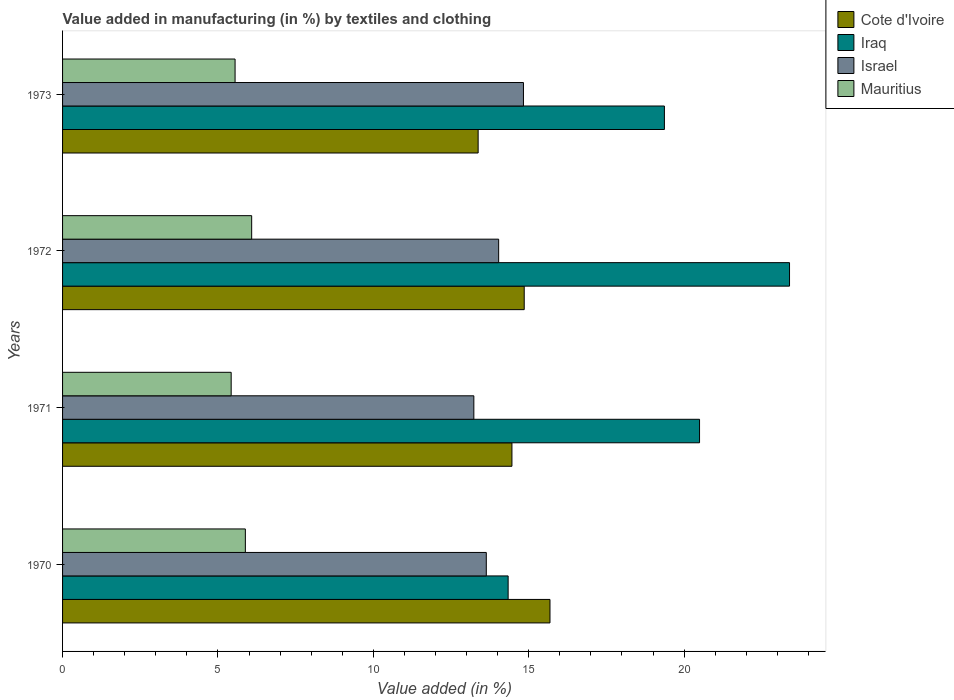How many different coloured bars are there?
Offer a terse response. 4. Are the number of bars per tick equal to the number of legend labels?
Your response must be concise. Yes. How many bars are there on the 1st tick from the top?
Provide a succinct answer. 4. What is the percentage of value added in manufacturing by textiles and clothing in Mauritius in 1970?
Provide a succinct answer. 5.88. Across all years, what is the maximum percentage of value added in manufacturing by textiles and clothing in Israel?
Give a very brief answer. 14.83. Across all years, what is the minimum percentage of value added in manufacturing by textiles and clothing in Mauritius?
Your answer should be compact. 5.43. In which year was the percentage of value added in manufacturing by textiles and clothing in Mauritius maximum?
Your response must be concise. 1972. In which year was the percentage of value added in manufacturing by textiles and clothing in Israel minimum?
Offer a terse response. 1971. What is the total percentage of value added in manufacturing by textiles and clothing in Mauritius in the graph?
Offer a very short reply. 22.94. What is the difference between the percentage of value added in manufacturing by textiles and clothing in Iraq in 1970 and that in 1972?
Provide a short and direct response. -9.06. What is the difference between the percentage of value added in manufacturing by textiles and clothing in Iraq in 1971 and the percentage of value added in manufacturing by textiles and clothing in Cote d'Ivoire in 1973?
Keep it short and to the point. 7.12. What is the average percentage of value added in manufacturing by textiles and clothing in Cote d'Ivoire per year?
Offer a terse response. 14.59. In the year 1971, what is the difference between the percentage of value added in manufacturing by textiles and clothing in Iraq and percentage of value added in manufacturing by textiles and clothing in Mauritius?
Make the answer very short. 15.07. What is the ratio of the percentage of value added in manufacturing by textiles and clothing in Cote d'Ivoire in 1970 to that in 1973?
Keep it short and to the point. 1.17. What is the difference between the highest and the second highest percentage of value added in manufacturing by textiles and clothing in Mauritius?
Your answer should be compact. 0.2. What is the difference between the highest and the lowest percentage of value added in manufacturing by textiles and clothing in Israel?
Your answer should be very brief. 1.6. Is it the case that in every year, the sum of the percentage of value added in manufacturing by textiles and clothing in Cote d'Ivoire and percentage of value added in manufacturing by textiles and clothing in Israel is greater than the sum of percentage of value added in manufacturing by textiles and clothing in Mauritius and percentage of value added in manufacturing by textiles and clothing in Iraq?
Give a very brief answer. Yes. What does the 3rd bar from the top in 1971 represents?
Keep it short and to the point. Iraq. What does the 4th bar from the bottom in 1973 represents?
Ensure brevity in your answer.  Mauritius. Are the values on the major ticks of X-axis written in scientific E-notation?
Offer a very short reply. No. Does the graph contain any zero values?
Provide a short and direct response. No. Where does the legend appear in the graph?
Ensure brevity in your answer.  Top right. How many legend labels are there?
Offer a very short reply. 4. What is the title of the graph?
Offer a very short reply. Value added in manufacturing (in %) by textiles and clothing. Does "Korea (Democratic)" appear as one of the legend labels in the graph?
Provide a short and direct response. No. What is the label or title of the X-axis?
Offer a very short reply. Value added (in %). What is the Value added (in %) of Cote d'Ivoire in 1970?
Provide a short and direct response. 15.68. What is the Value added (in %) of Iraq in 1970?
Make the answer very short. 14.34. What is the Value added (in %) of Israel in 1970?
Offer a very short reply. 13.64. What is the Value added (in %) of Mauritius in 1970?
Keep it short and to the point. 5.88. What is the Value added (in %) of Cote d'Ivoire in 1971?
Your answer should be very brief. 14.46. What is the Value added (in %) of Iraq in 1971?
Your answer should be very brief. 20.5. What is the Value added (in %) of Israel in 1971?
Offer a very short reply. 13.23. What is the Value added (in %) in Mauritius in 1971?
Provide a short and direct response. 5.43. What is the Value added (in %) of Cote d'Ivoire in 1972?
Your answer should be compact. 14.86. What is the Value added (in %) of Iraq in 1972?
Your answer should be compact. 23.39. What is the Value added (in %) of Israel in 1972?
Ensure brevity in your answer.  14.03. What is the Value added (in %) in Mauritius in 1972?
Give a very brief answer. 6.09. What is the Value added (in %) of Cote d'Ivoire in 1973?
Offer a very short reply. 13.37. What is the Value added (in %) in Iraq in 1973?
Ensure brevity in your answer.  19.37. What is the Value added (in %) of Israel in 1973?
Offer a very short reply. 14.83. What is the Value added (in %) in Mauritius in 1973?
Your answer should be very brief. 5.55. Across all years, what is the maximum Value added (in %) of Cote d'Ivoire?
Give a very brief answer. 15.68. Across all years, what is the maximum Value added (in %) of Iraq?
Your answer should be compact. 23.39. Across all years, what is the maximum Value added (in %) in Israel?
Make the answer very short. 14.83. Across all years, what is the maximum Value added (in %) in Mauritius?
Your answer should be very brief. 6.09. Across all years, what is the minimum Value added (in %) in Cote d'Ivoire?
Keep it short and to the point. 13.37. Across all years, what is the minimum Value added (in %) in Iraq?
Provide a short and direct response. 14.34. Across all years, what is the minimum Value added (in %) of Israel?
Give a very brief answer. 13.23. Across all years, what is the minimum Value added (in %) in Mauritius?
Offer a terse response. 5.43. What is the total Value added (in %) in Cote d'Ivoire in the graph?
Provide a short and direct response. 58.37. What is the total Value added (in %) of Iraq in the graph?
Provide a succinct answer. 77.6. What is the total Value added (in %) of Israel in the graph?
Your answer should be compact. 55.73. What is the total Value added (in %) of Mauritius in the graph?
Ensure brevity in your answer.  22.94. What is the difference between the Value added (in %) in Cote d'Ivoire in 1970 and that in 1971?
Offer a very short reply. 1.22. What is the difference between the Value added (in %) of Iraq in 1970 and that in 1971?
Your answer should be very brief. -6.16. What is the difference between the Value added (in %) of Israel in 1970 and that in 1971?
Give a very brief answer. 0.4. What is the difference between the Value added (in %) of Mauritius in 1970 and that in 1971?
Provide a short and direct response. 0.46. What is the difference between the Value added (in %) of Cote d'Ivoire in 1970 and that in 1972?
Provide a succinct answer. 0.83. What is the difference between the Value added (in %) in Iraq in 1970 and that in 1972?
Give a very brief answer. -9.06. What is the difference between the Value added (in %) of Israel in 1970 and that in 1972?
Provide a succinct answer. -0.4. What is the difference between the Value added (in %) of Mauritius in 1970 and that in 1972?
Your answer should be compact. -0.2. What is the difference between the Value added (in %) in Cote d'Ivoire in 1970 and that in 1973?
Keep it short and to the point. 2.31. What is the difference between the Value added (in %) in Iraq in 1970 and that in 1973?
Offer a terse response. -5.03. What is the difference between the Value added (in %) in Israel in 1970 and that in 1973?
Offer a very short reply. -1.2. What is the difference between the Value added (in %) of Mauritius in 1970 and that in 1973?
Your response must be concise. 0.33. What is the difference between the Value added (in %) in Cote d'Ivoire in 1971 and that in 1972?
Provide a succinct answer. -0.4. What is the difference between the Value added (in %) in Iraq in 1971 and that in 1972?
Make the answer very short. -2.9. What is the difference between the Value added (in %) in Israel in 1971 and that in 1972?
Your answer should be compact. -0.8. What is the difference between the Value added (in %) in Mauritius in 1971 and that in 1972?
Offer a terse response. -0.66. What is the difference between the Value added (in %) of Cote d'Ivoire in 1971 and that in 1973?
Give a very brief answer. 1.09. What is the difference between the Value added (in %) in Iraq in 1971 and that in 1973?
Your answer should be compact. 1.13. What is the difference between the Value added (in %) of Israel in 1971 and that in 1973?
Your response must be concise. -1.6. What is the difference between the Value added (in %) of Mauritius in 1971 and that in 1973?
Keep it short and to the point. -0.13. What is the difference between the Value added (in %) of Cote d'Ivoire in 1972 and that in 1973?
Your answer should be very brief. 1.48. What is the difference between the Value added (in %) of Iraq in 1972 and that in 1973?
Your response must be concise. 4.03. What is the difference between the Value added (in %) in Israel in 1972 and that in 1973?
Keep it short and to the point. -0.8. What is the difference between the Value added (in %) in Mauritius in 1972 and that in 1973?
Offer a very short reply. 0.53. What is the difference between the Value added (in %) of Cote d'Ivoire in 1970 and the Value added (in %) of Iraq in 1971?
Your answer should be very brief. -4.81. What is the difference between the Value added (in %) in Cote d'Ivoire in 1970 and the Value added (in %) in Israel in 1971?
Give a very brief answer. 2.45. What is the difference between the Value added (in %) in Cote d'Ivoire in 1970 and the Value added (in %) in Mauritius in 1971?
Make the answer very short. 10.26. What is the difference between the Value added (in %) of Iraq in 1970 and the Value added (in %) of Israel in 1971?
Make the answer very short. 1.1. What is the difference between the Value added (in %) in Iraq in 1970 and the Value added (in %) in Mauritius in 1971?
Provide a succinct answer. 8.91. What is the difference between the Value added (in %) of Israel in 1970 and the Value added (in %) of Mauritius in 1971?
Offer a terse response. 8.21. What is the difference between the Value added (in %) in Cote d'Ivoire in 1970 and the Value added (in %) in Iraq in 1972?
Your answer should be very brief. -7.71. What is the difference between the Value added (in %) in Cote d'Ivoire in 1970 and the Value added (in %) in Israel in 1972?
Ensure brevity in your answer.  1.65. What is the difference between the Value added (in %) in Cote d'Ivoire in 1970 and the Value added (in %) in Mauritius in 1972?
Keep it short and to the point. 9.6. What is the difference between the Value added (in %) in Iraq in 1970 and the Value added (in %) in Israel in 1972?
Your response must be concise. 0.3. What is the difference between the Value added (in %) of Iraq in 1970 and the Value added (in %) of Mauritius in 1972?
Keep it short and to the point. 8.25. What is the difference between the Value added (in %) in Israel in 1970 and the Value added (in %) in Mauritius in 1972?
Your answer should be very brief. 7.55. What is the difference between the Value added (in %) in Cote d'Ivoire in 1970 and the Value added (in %) in Iraq in 1973?
Your answer should be very brief. -3.68. What is the difference between the Value added (in %) of Cote d'Ivoire in 1970 and the Value added (in %) of Israel in 1973?
Your answer should be very brief. 0.85. What is the difference between the Value added (in %) of Cote d'Ivoire in 1970 and the Value added (in %) of Mauritius in 1973?
Your answer should be very brief. 10.13. What is the difference between the Value added (in %) of Iraq in 1970 and the Value added (in %) of Israel in 1973?
Provide a succinct answer. -0.49. What is the difference between the Value added (in %) of Iraq in 1970 and the Value added (in %) of Mauritius in 1973?
Ensure brevity in your answer.  8.79. What is the difference between the Value added (in %) in Israel in 1970 and the Value added (in %) in Mauritius in 1973?
Your answer should be very brief. 8.08. What is the difference between the Value added (in %) in Cote d'Ivoire in 1971 and the Value added (in %) in Iraq in 1972?
Keep it short and to the point. -8.93. What is the difference between the Value added (in %) of Cote d'Ivoire in 1971 and the Value added (in %) of Israel in 1972?
Ensure brevity in your answer.  0.43. What is the difference between the Value added (in %) of Cote d'Ivoire in 1971 and the Value added (in %) of Mauritius in 1972?
Give a very brief answer. 8.38. What is the difference between the Value added (in %) in Iraq in 1971 and the Value added (in %) in Israel in 1972?
Make the answer very short. 6.46. What is the difference between the Value added (in %) of Iraq in 1971 and the Value added (in %) of Mauritius in 1972?
Offer a very short reply. 14.41. What is the difference between the Value added (in %) of Israel in 1971 and the Value added (in %) of Mauritius in 1972?
Ensure brevity in your answer.  7.15. What is the difference between the Value added (in %) in Cote d'Ivoire in 1971 and the Value added (in %) in Iraq in 1973?
Make the answer very short. -4.91. What is the difference between the Value added (in %) of Cote d'Ivoire in 1971 and the Value added (in %) of Israel in 1973?
Ensure brevity in your answer.  -0.37. What is the difference between the Value added (in %) of Cote d'Ivoire in 1971 and the Value added (in %) of Mauritius in 1973?
Offer a very short reply. 8.91. What is the difference between the Value added (in %) in Iraq in 1971 and the Value added (in %) in Israel in 1973?
Your response must be concise. 5.67. What is the difference between the Value added (in %) in Iraq in 1971 and the Value added (in %) in Mauritius in 1973?
Your answer should be compact. 14.95. What is the difference between the Value added (in %) in Israel in 1971 and the Value added (in %) in Mauritius in 1973?
Keep it short and to the point. 7.68. What is the difference between the Value added (in %) of Cote d'Ivoire in 1972 and the Value added (in %) of Iraq in 1973?
Your answer should be very brief. -4.51. What is the difference between the Value added (in %) in Cote d'Ivoire in 1972 and the Value added (in %) in Israel in 1973?
Ensure brevity in your answer.  0.02. What is the difference between the Value added (in %) of Cote d'Ivoire in 1972 and the Value added (in %) of Mauritius in 1973?
Ensure brevity in your answer.  9.3. What is the difference between the Value added (in %) of Iraq in 1972 and the Value added (in %) of Israel in 1973?
Give a very brief answer. 8.56. What is the difference between the Value added (in %) of Iraq in 1972 and the Value added (in %) of Mauritius in 1973?
Give a very brief answer. 17.84. What is the difference between the Value added (in %) of Israel in 1972 and the Value added (in %) of Mauritius in 1973?
Keep it short and to the point. 8.48. What is the average Value added (in %) in Cote d'Ivoire per year?
Provide a short and direct response. 14.59. What is the average Value added (in %) of Iraq per year?
Keep it short and to the point. 19.4. What is the average Value added (in %) in Israel per year?
Give a very brief answer. 13.93. What is the average Value added (in %) of Mauritius per year?
Your response must be concise. 5.74. In the year 1970, what is the difference between the Value added (in %) of Cote d'Ivoire and Value added (in %) of Iraq?
Your response must be concise. 1.35. In the year 1970, what is the difference between the Value added (in %) of Cote d'Ivoire and Value added (in %) of Israel?
Provide a short and direct response. 2.05. In the year 1970, what is the difference between the Value added (in %) of Cote d'Ivoire and Value added (in %) of Mauritius?
Offer a very short reply. 9.8. In the year 1970, what is the difference between the Value added (in %) of Iraq and Value added (in %) of Israel?
Make the answer very short. 0.7. In the year 1970, what is the difference between the Value added (in %) of Iraq and Value added (in %) of Mauritius?
Make the answer very short. 8.46. In the year 1970, what is the difference between the Value added (in %) in Israel and Value added (in %) in Mauritius?
Ensure brevity in your answer.  7.75. In the year 1971, what is the difference between the Value added (in %) in Cote d'Ivoire and Value added (in %) in Iraq?
Provide a succinct answer. -6.04. In the year 1971, what is the difference between the Value added (in %) of Cote d'Ivoire and Value added (in %) of Israel?
Provide a short and direct response. 1.23. In the year 1971, what is the difference between the Value added (in %) in Cote d'Ivoire and Value added (in %) in Mauritius?
Give a very brief answer. 9.03. In the year 1971, what is the difference between the Value added (in %) of Iraq and Value added (in %) of Israel?
Provide a succinct answer. 7.26. In the year 1971, what is the difference between the Value added (in %) of Iraq and Value added (in %) of Mauritius?
Your response must be concise. 15.07. In the year 1971, what is the difference between the Value added (in %) of Israel and Value added (in %) of Mauritius?
Your response must be concise. 7.81. In the year 1972, what is the difference between the Value added (in %) of Cote d'Ivoire and Value added (in %) of Iraq?
Give a very brief answer. -8.54. In the year 1972, what is the difference between the Value added (in %) of Cote d'Ivoire and Value added (in %) of Israel?
Your answer should be compact. 0.82. In the year 1972, what is the difference between the Value added (in %) of Cote d'Ivoire and Value added (in %) of Mauritius?
Your answer should be compact. 8.77. In the year 1972, what is the difference between the Value added (in %) of Iraq and Value added (in %) of Israel?
Ensure brevity in your answer.  9.36. In the year 1972, what is the difference between the Value added (in %) of Iraq and Value added (in %) of Mauritius?
Make the answer very short. 17.31. In the year 1972, what is the difference between the Value added (in %) of Israel and Value added (in %) of Mauritius?
Make the answer very short. 7.95. In the year 1973, what is the difference between the Value added (in %) in Cote d'Ivoire and Value added (in %) in Iraq?
Your response must be concise. -5.99. In the year 1973, what is the difference between the Value added (in %) in Cote d'Ivoire and Value added (in %) in Israel?
Offer a terse response. -1.46. In the year 1973, what is the difference between the Value added (in %) of Cote d'Ivoire and Value added (in %) of Mauritius?
Offer a very short reply. 7.82. In the year 1973, what is the difference between the Value added (in %) in Iraq and Value added (in %) in Israel?
Provide a succinct answer. 4.54. In the year 1973, what is the difference between the Value added (in %) of Iraq and Value added (in %) of Mauritius?
Your answer should be very brief. 13.82. In the year 1973, what is the difference between the Value added (in %) in Israel and Value added (in %) in Mauritius?
Offer a terse response. 9.28. What is the ratio of the Value added (in %) of Cote d'Ivoire in 1970 to that in 1971?
Make the answer very short. 1.08. What is the ratio of the Value added (in %) in Iraq in 1970 to that in 1971?
Provide a succinct answer. 0.7. What is the ratio of the Value added (in %) in Israel in 1970 to that in 1971?
Offer a very short reply. 1.03. What is the ratio of the Value added (in %) of Mauritius in 1970 to that in 1971?
Provide a succinct answer. 1.08. What is the ratio of the Value added (in %) in Cote d'Ivoire in 1970 to that in 1972?
Keep it short and to the point. 1.06. What is the ratio of the Value added (in %) of Iraq in 1970 to that in 1972?
Offer a very short reply. 0.61. What is the ratio of the Value added (in %) of Israel in 1970 to that in 1972?
Your response must be concise. 0.97. What is the ratio of the Value added (in %) in Mauritius in 1970 to that in 1972?
Give a very brief answer. 0.97. What is the ratio of the Value added (in %) of Cote d'Ivoire in 1970 to that in 1973?
Ensure brevity in your answer.  1.17. What is the ratio of the Value added (in %) of Iraq in 1970 to that in 1973?
Make the answer very short. 0.74. What is the ratio of the Value added (in %) in Israel in 1970 to that in 1973?
Offer a very short reply. 0.92. What is the ratio of the Value added (in %) in Mauritius in 1970 to that in 1973?
Give a very brief answer. 1.06. What is the ratio of the Value added (in %) of Cote d'Ivoire in 1971 to that in 1972?
Make the answer very short. 0.97. What is the ratio of the Value added (in %) in Iraq in 1971 to that in 1972?
Your response must be concise. 0.88. What is the ratio of the Value added (in %) in Israel in 1971 to that in 1972?
Offer a terse response. 0.94. What is the ratio of the Value added (in %) in Mauritius in 1971 to that in 1972?
Offer a terse response. 0.89. What is the ratio of the Value added (in %) of Cote d'Ivoire in 1971 to that in 1973?
Ensure brevity in your answer.  1.08. What is the ratio of the Value added (in %) of Iraq in 1971 to that in 1973?
Offer a very short reply. 1.06. What is the ratio of the Value added (in %) of Israel in 1971 to that in 1973?
Offer a very short reply. 0.89. What is the ratio of the Value added (in %) of Mauritius in 1971 to that in 1973?
Offer a very short reply. 0.98. What is the ratio of the Value added (in %) of Cote d'Ivoire in 1972 to that in 1973?
Give a very brief answer. 1.11. What is the ratio of the Value added (in %) in Iraq in 1972 to that in 1973?
Your response must be concise. 1.21. What is the ratio of the Value added (in %) of Israel in 1972 to that in 1973?
Ensure brevity in your answer.  0.95. What is the ratio of the Value added (in %) of Mauritius in 1972 to that in 1973?
Your answer should be compact. 1.1. What is the difference between the highest and the second highest Value added (in %) in Cote d'Ivoire?
Ensure brevity in your answer.  0.83. What is the difference between the highest and the second highest Value added (in %) in Iraq?
Offer a very short reply. 2.9. What is the difference between the highest and the second highest Value added (in %) of Israel?
Ensure brevity in your answer.  0.8. What is the difference between the highest and the second highest Value added (in %) of Mauritius?
Make the answer very short. 0.2. What is the difference between the highest and the lowest Value added (in %) of Cote d'Ivoire?
Provide a succinct answer. 2.31. What is the difference between the highest and the lowest Value added (in %) of Iraq?
Your answer should be very brief. 9.06. What is the difference between the highest and the lowest Value added (in %) in Israel?
Provide a succinct answer. 1.6. What is the difference between the highest and the lowest Value added (in %) in Mauritius?
Make the answer very short. 0.66. 